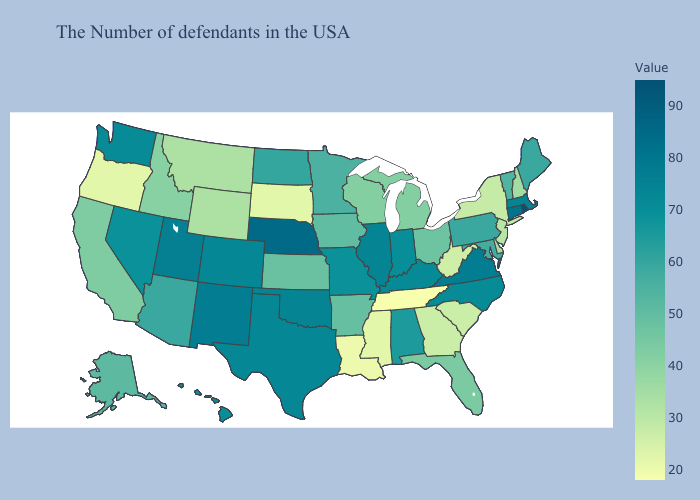Among the states that border Kansas , does Nebraska have the lowest value?
Give a very brief answer. No. Which states have the lowest value in the South?
Short answer required. Tennessee. Which states hav the highest value in the MidWest?
Quick response, please. Nebraska. Among the states that border North Carolina , does South Carolina have the lowest value?
Answer briefly. No. Does the map have missing data?
Answer briefly. No. Which states have the lowest value in the USA?
Keep it brief. Tennessee. Which states have the lowest value in the USA?
Short answer required. Tennessee. Which states have the lowest value in the West?
Be succinct. Oregon. 